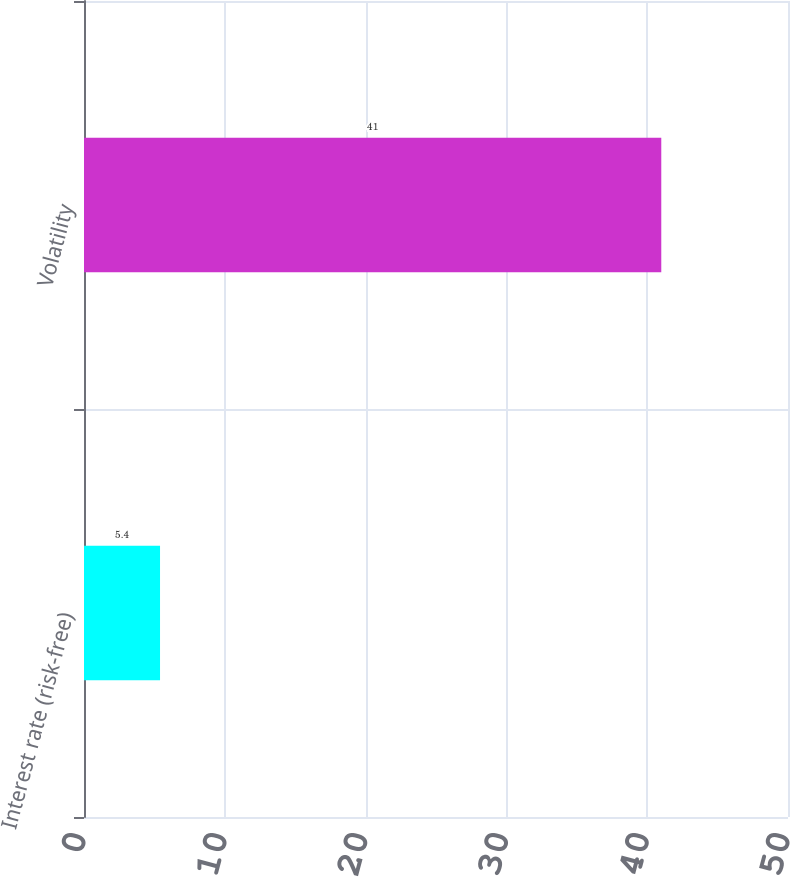<chart> <loc_0><loc_0><loc_500><loc_500><bar_chart><fcel>Interest rate (risk-free)<fcel>Volatility<nl><fcel>5.4<fcel>41<nl></chart> 